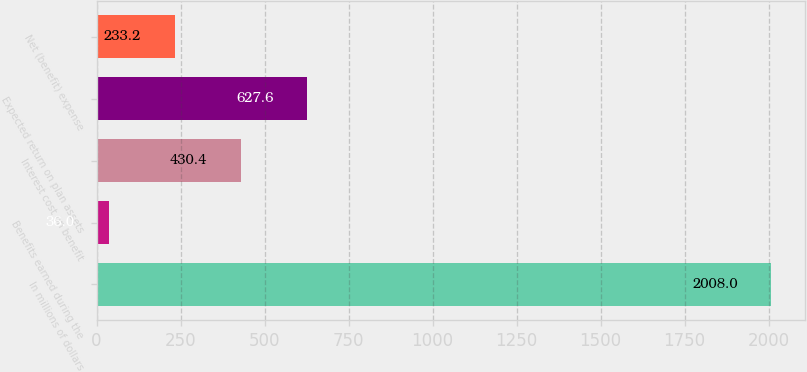Convert chart. <chart><loc_0><loc_0><loc_500><loc_500><bar_chart><fcel>In millions of dollars<fcel>Benefits earned during the<fcel>Interest cost on benefit<fcel>Expected return on plan assets<fcel>Net (benefit) expense<nl><fcel>2008<fcel>36<fcel>430.4<fcel>627.6<fcel>233.2<nl></chart> 